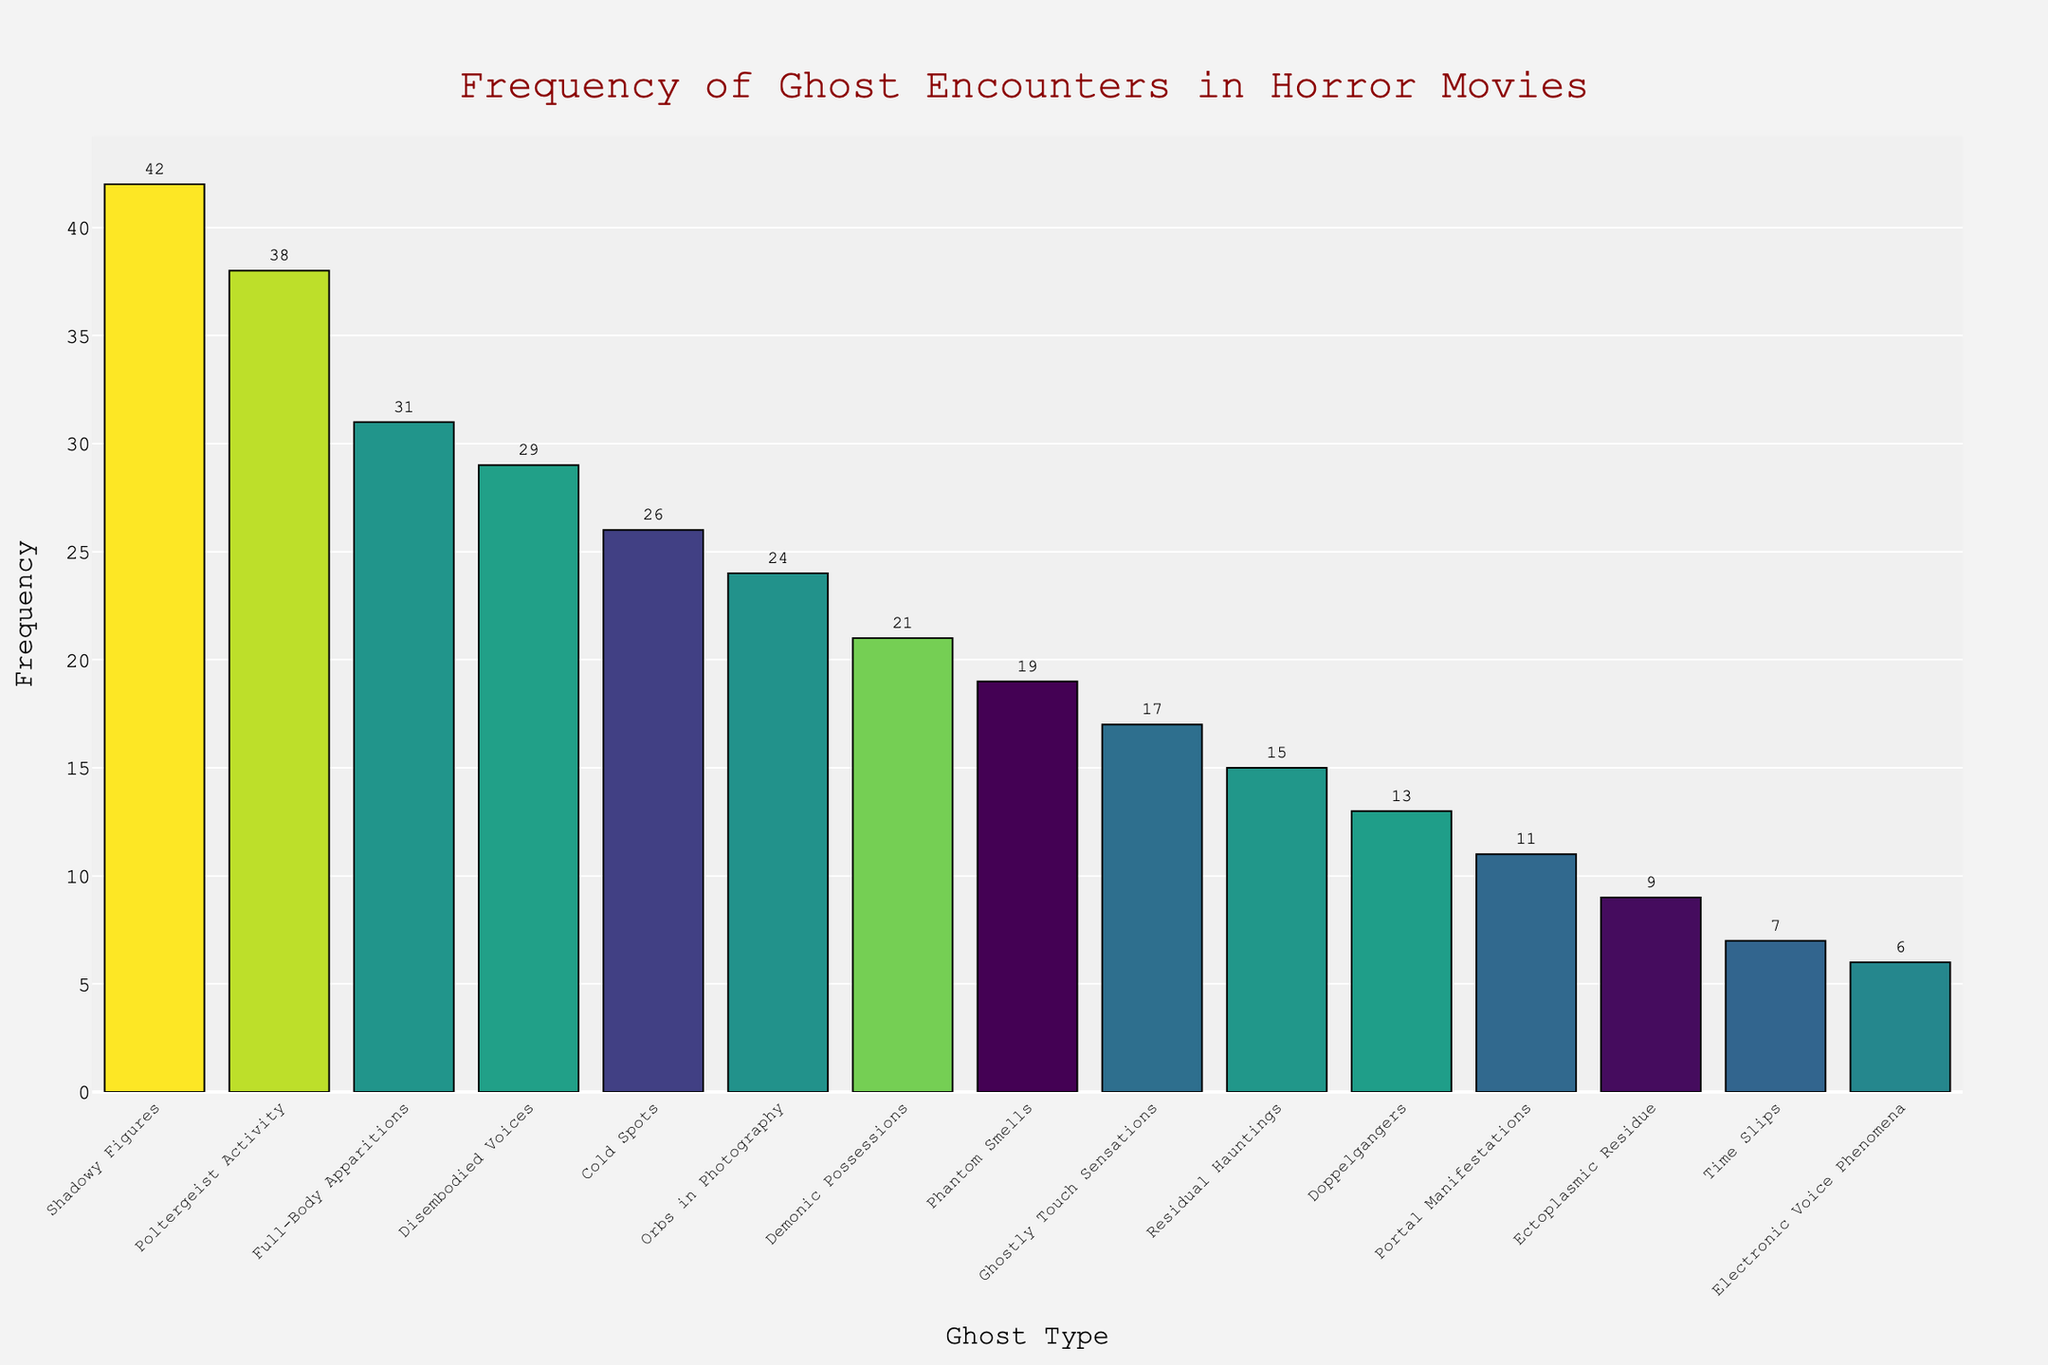Which ghostly phenomenon is reported most frequently in horror movies? The bar representing Shadowy Figures is the highest, indicating it has the highest frequency.
Answer: Shadowy Figures How does the frequency of Poltergeist Activity compare to Full-Body Apparitions? The bar for Poltergeist Activity is higher than the bar for Full-Body Apparitions, showing that Poltergeist Activity is more frequent.
Answer: Poltergeist Activity is more frequent What is the total frequency of Disembodied Voices and Cold Spots combined? The frequency of Disembodied Voices is 29 and Cold Spots is 26. Adding them gives 29 + 26 = 55.
Answer: 55 Is there a significant difference in frequency between Phantom Smells and Ghostly Touch Sensations? Phantom Smells have a frequency of 19, while Ghostly Touch Sensations have 17. The difference is 19 - 17 = 2, which is not substantial.
Answer: No Which is less frequently reported, Portal Manifestations or Ectoplasmic Residue? The bar for Ectoplasmic Residue is shorter than the bar for Portal Manifestations, showing that Ectoplasmic Residue is reported less often.
Answer: Ectoplasmic Residue What is the average frequency of the top five most commonly reported ghost encounters? The frequencies of the top five are Shadowy Figures (42), Poltergeist Activity (38), Full-Body Apparitions (31), Disembodied Voices (29), and Cold Spots (26). The sum is 42 + 38 + 31 + 29 + 26 = 166. The average is 166 / 5 = 33.2.
Answer: 33.2 Are Orbs in Photography reported more frequently or less frequently than Demonic Possessions? Orbs in Photography have a frequency of 24, while Demonic Possessions have 21, so Orbs in Photography are reported more frequently.
Answer: More frequently What is the median frequency of all the ghost encounters reported? To find the median, list all frequencies in order: 6, 7, 9, 11, 13, 15, 17, 19, 21, 24, 26, 29, 31, 38, 42. The middle value (8th in 15 values) is 19.
Answer: 19 What is the frequency range of the reported ghost encounters? The frequency range is the difference between the highest and the lowest values. Here, it's 42 (Shadowy Figures) - 6 (Electronic Voice Phenomena) = 36.
Answer: 36 If we combine the frequency of Doppelgangers and Time Slips, how does it compare to Full-Body Apparitions? Doppelgangers have a frequency of 13 and Time Slips 7, combining to 13 + 7 = 20. This is less than the frequency of Full-Body Apparitions, which is 31.
Answer: Less 